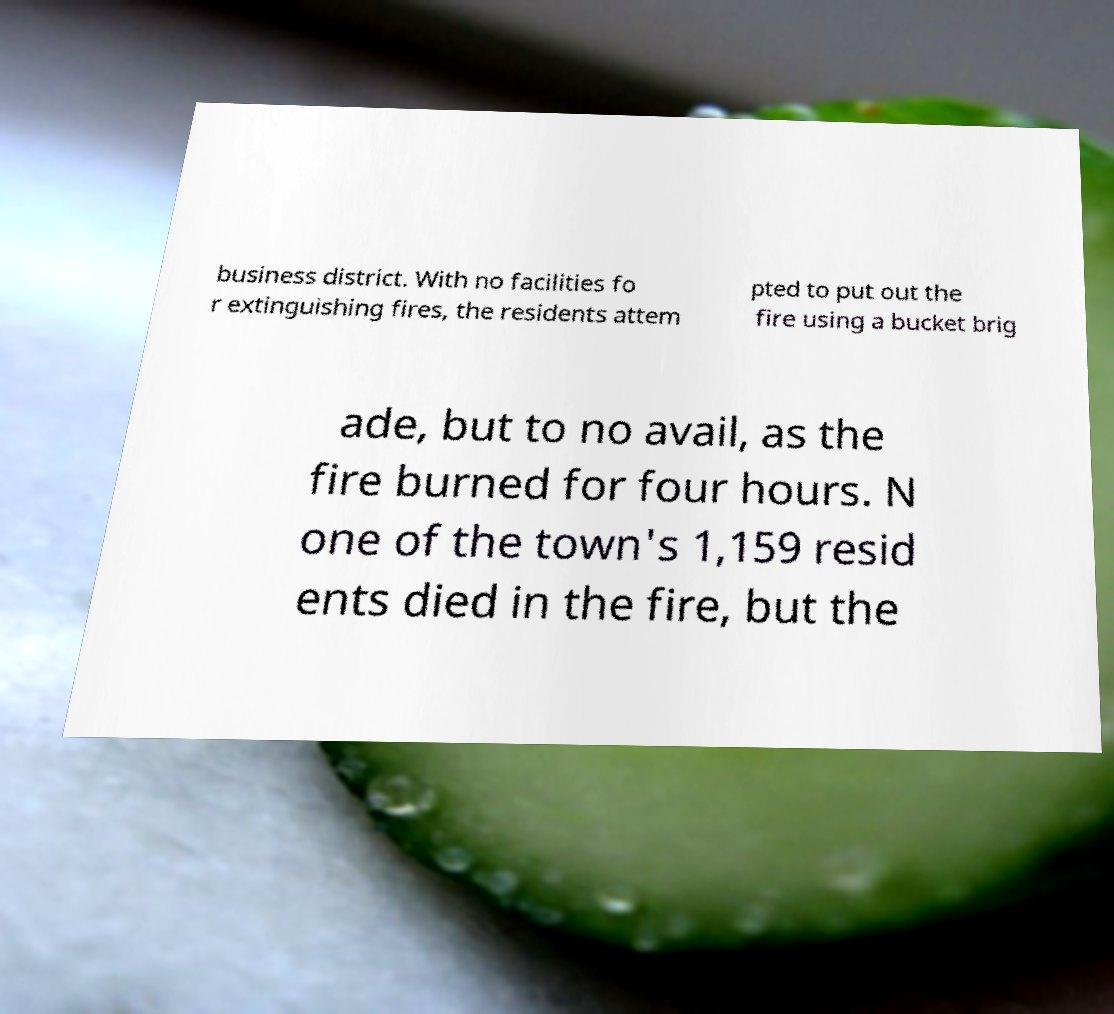Please read and relay the text visible in this image. What does it say? business district. With no facilities fo r extinguishing fires, the residents attem pted to put out the fire using a bucket brig ade, but to no avail, as the fire burned for four hours. N one of the town's 1,159 resid ents died in the fire, but the 